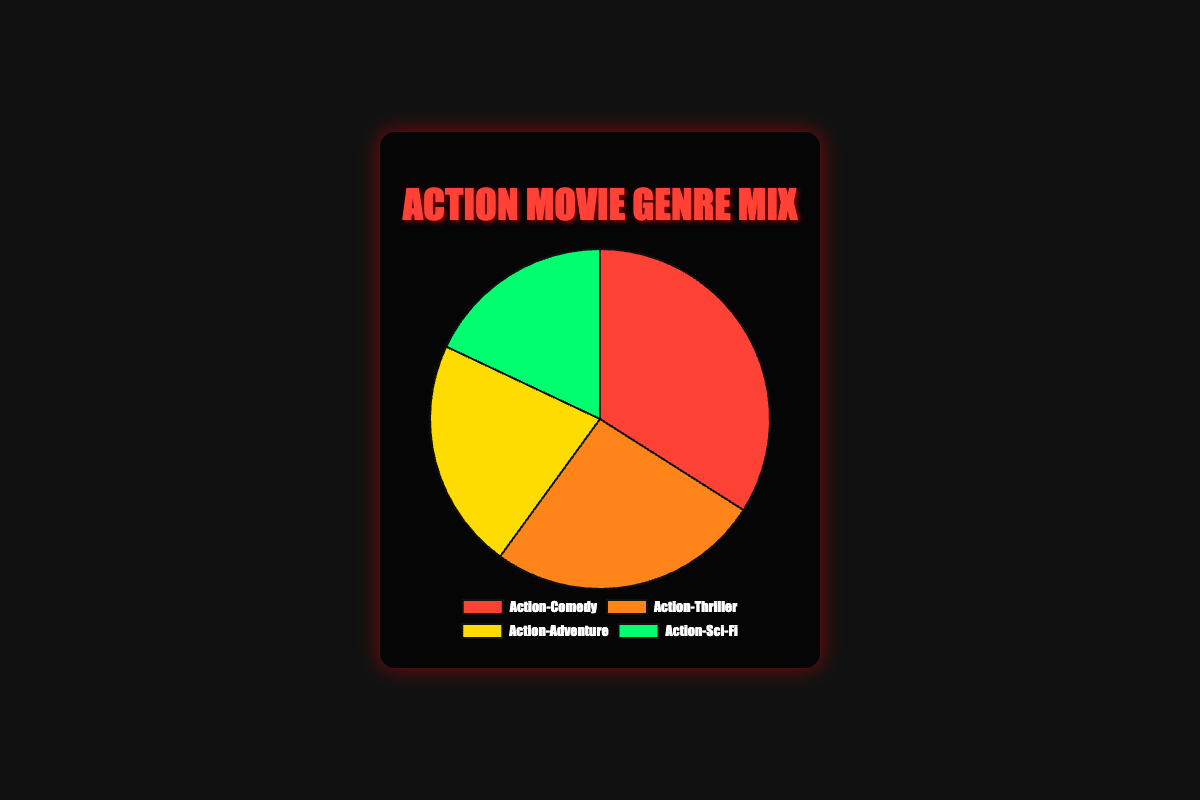Which genre mix has the largest share in the pie chart? The pie chart shows four genres where Action-Comedy occupies the largest portion of the pie chart.
Answer: Action-Comedy What is the combined percentage of Action-Thriller and Action-Adventure genres in the pie chart? Add the percentages of Action-Thriller (26%) and Action-Adventure (22%) to get the combined percentage. 26 + 22 = 48
Answer: 48% Which genre mix contributes the least in the pie chart? The pie chart clearly shows that Action-Sci-Fi has the smallest segment.
Answer: Action-Sci-Fi How much more popular is Action-Comedy compared to Action-Sci-Fi according to the pie chart? Subtract the percentage of Action-Sci-Fi (18%) from the percentage of Action-Comedy (34%) to find the difference. 34 - 18 = 16
Answer: 16% Which genre mixes in the pie chart make up more than half of the total percentage when combined? Combine the percentages of Action-Comedy (34%) and Action-Thriller (26%), resulting in 60, which is more than half.
Answer: Action-Comedy and Action-Thriller List the colors representing each genre mix in the pie chart. The pie chart uses different colors: red for Action-Comedy, orange for Action-Thriller, yellow for Action-Adventure, and green for Action-Sci-Fi.
Answer: Red, Orange, Yellow, Green If you add the percentages of the two least popular genres, what's the total percentage? Add the percentages of Action-Adventure (22%) and Action-Sci-Fi (18%). 22 + 18 = 40
Answer: 40% Rank the genre mixes in descending order of their percentages as shown in the pie chart. Look at the pie chart percentages: 1) Action-Comedy (34%), 2) Action-Thriller (26%), 3) Action-Adventure (22%), 4) Action-Sci-Fi (18%).
Answer: Action-Comedy, Action-Thriller, Action-Adventure, Action-Sci-Fi What is the difference between the percentages of the most and least popular genre mixes in the pie chart? Subtract the percentage of the least popular genre (Action-Sci-Fi, 18%) from the most popular genre (Action-Comedy, 34%). 34 - 18 = 16
Answer: 16% 